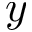Convert formula to latex. <formula><loc_0><loc_0><loc_500><loc_500>y</formula> 